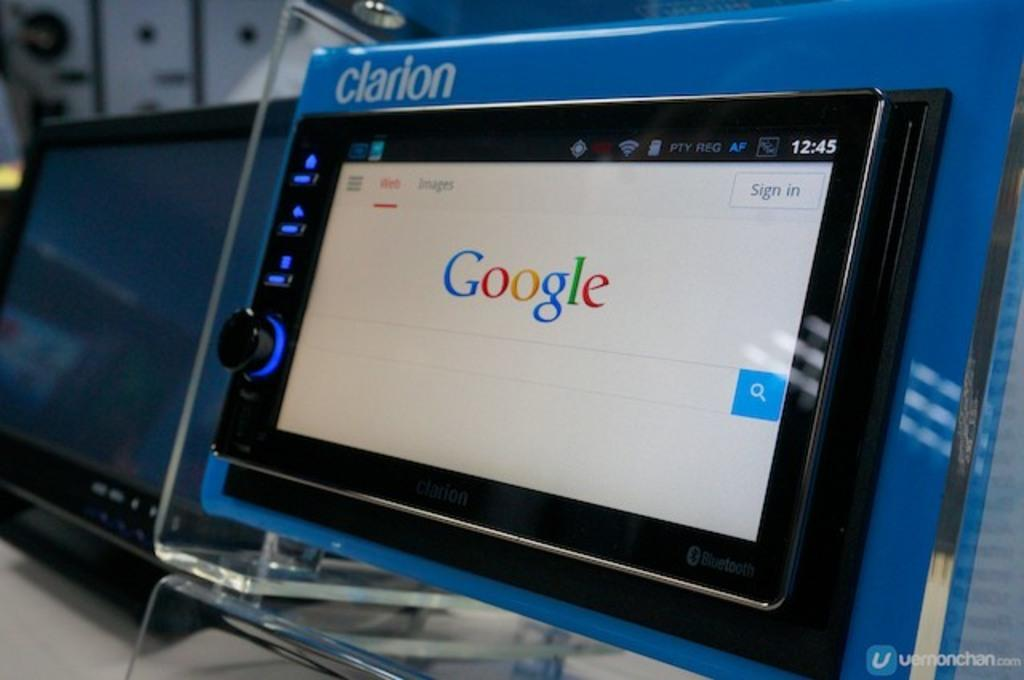What electronic device is on a stand in the image? There is a tablet on a stand in the image. What other electronic device is present in the image? There is a monitor on a table in the image. What level of squareness can be observed in the tablet's design? The tablet's design is not described in terms of squareness in the image, so it cannot be determined from the image. 